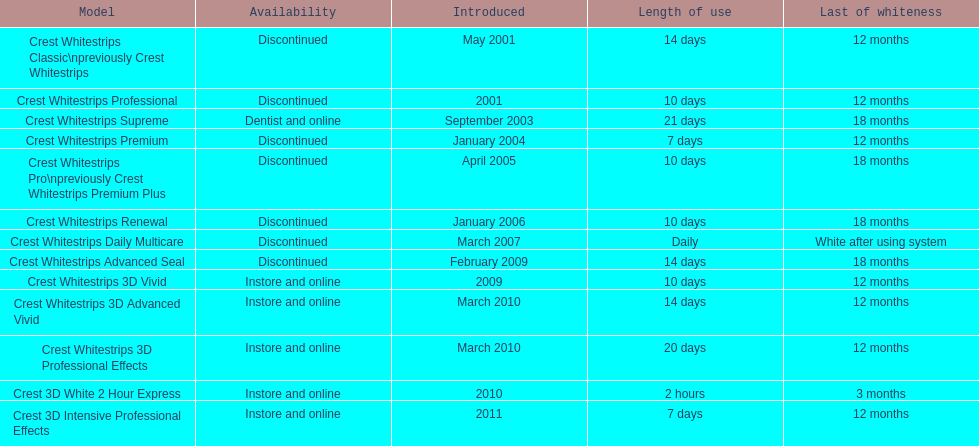In the same month as crest whitestrips 3d advanced vivid's introduction, what other product was released? Crest Whitestrips 3D Professional Effects. 